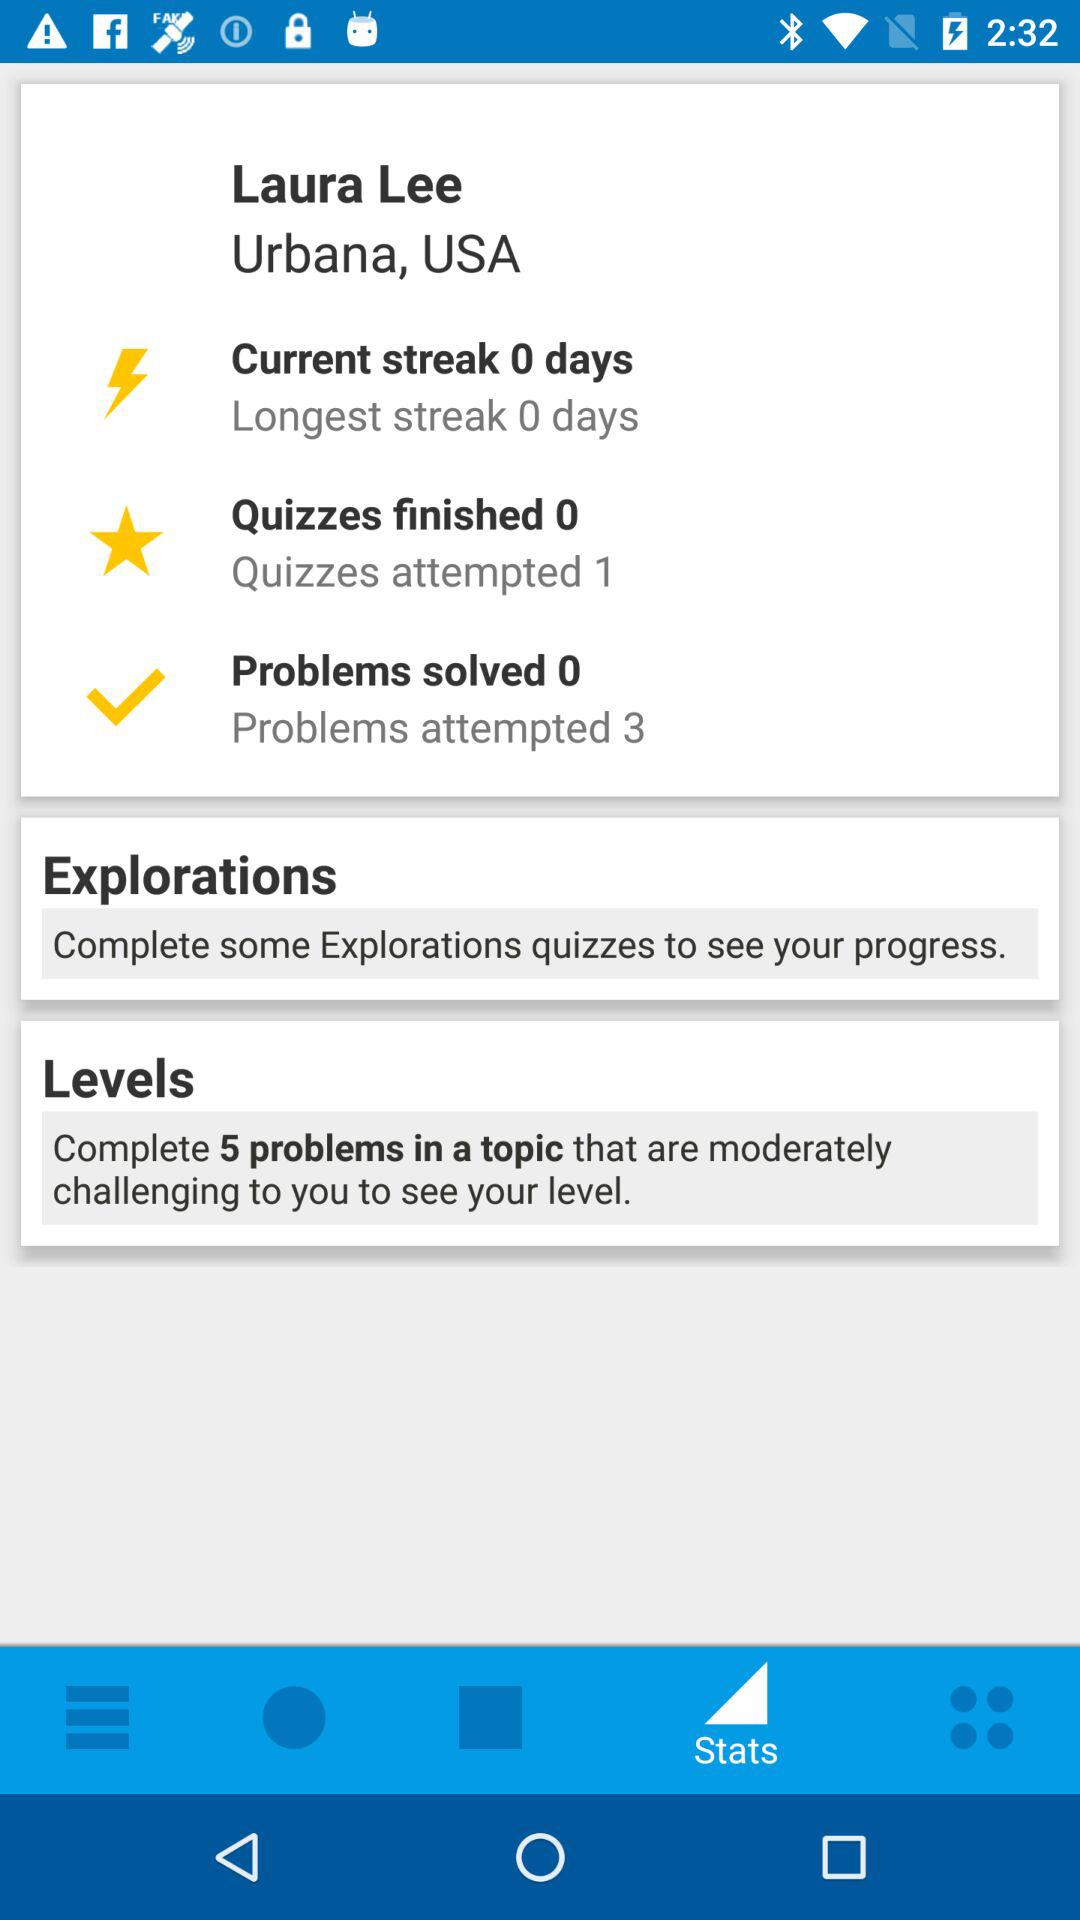How many problems are there in the Level?
When the provided information is insufficient, respond with <no answer>. <no answer> 